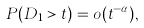Convert formula to latex. <formula><loc_0><loc_0><loc_500><loc_500>P ( D _ { 1 } > t ) = o ( t ^ { - \alpha } ) ,</formula> 